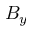Convert formula to latex. <formula><loc_0><loc_0><loc_500><loc_500>B _ { y }</formula> 